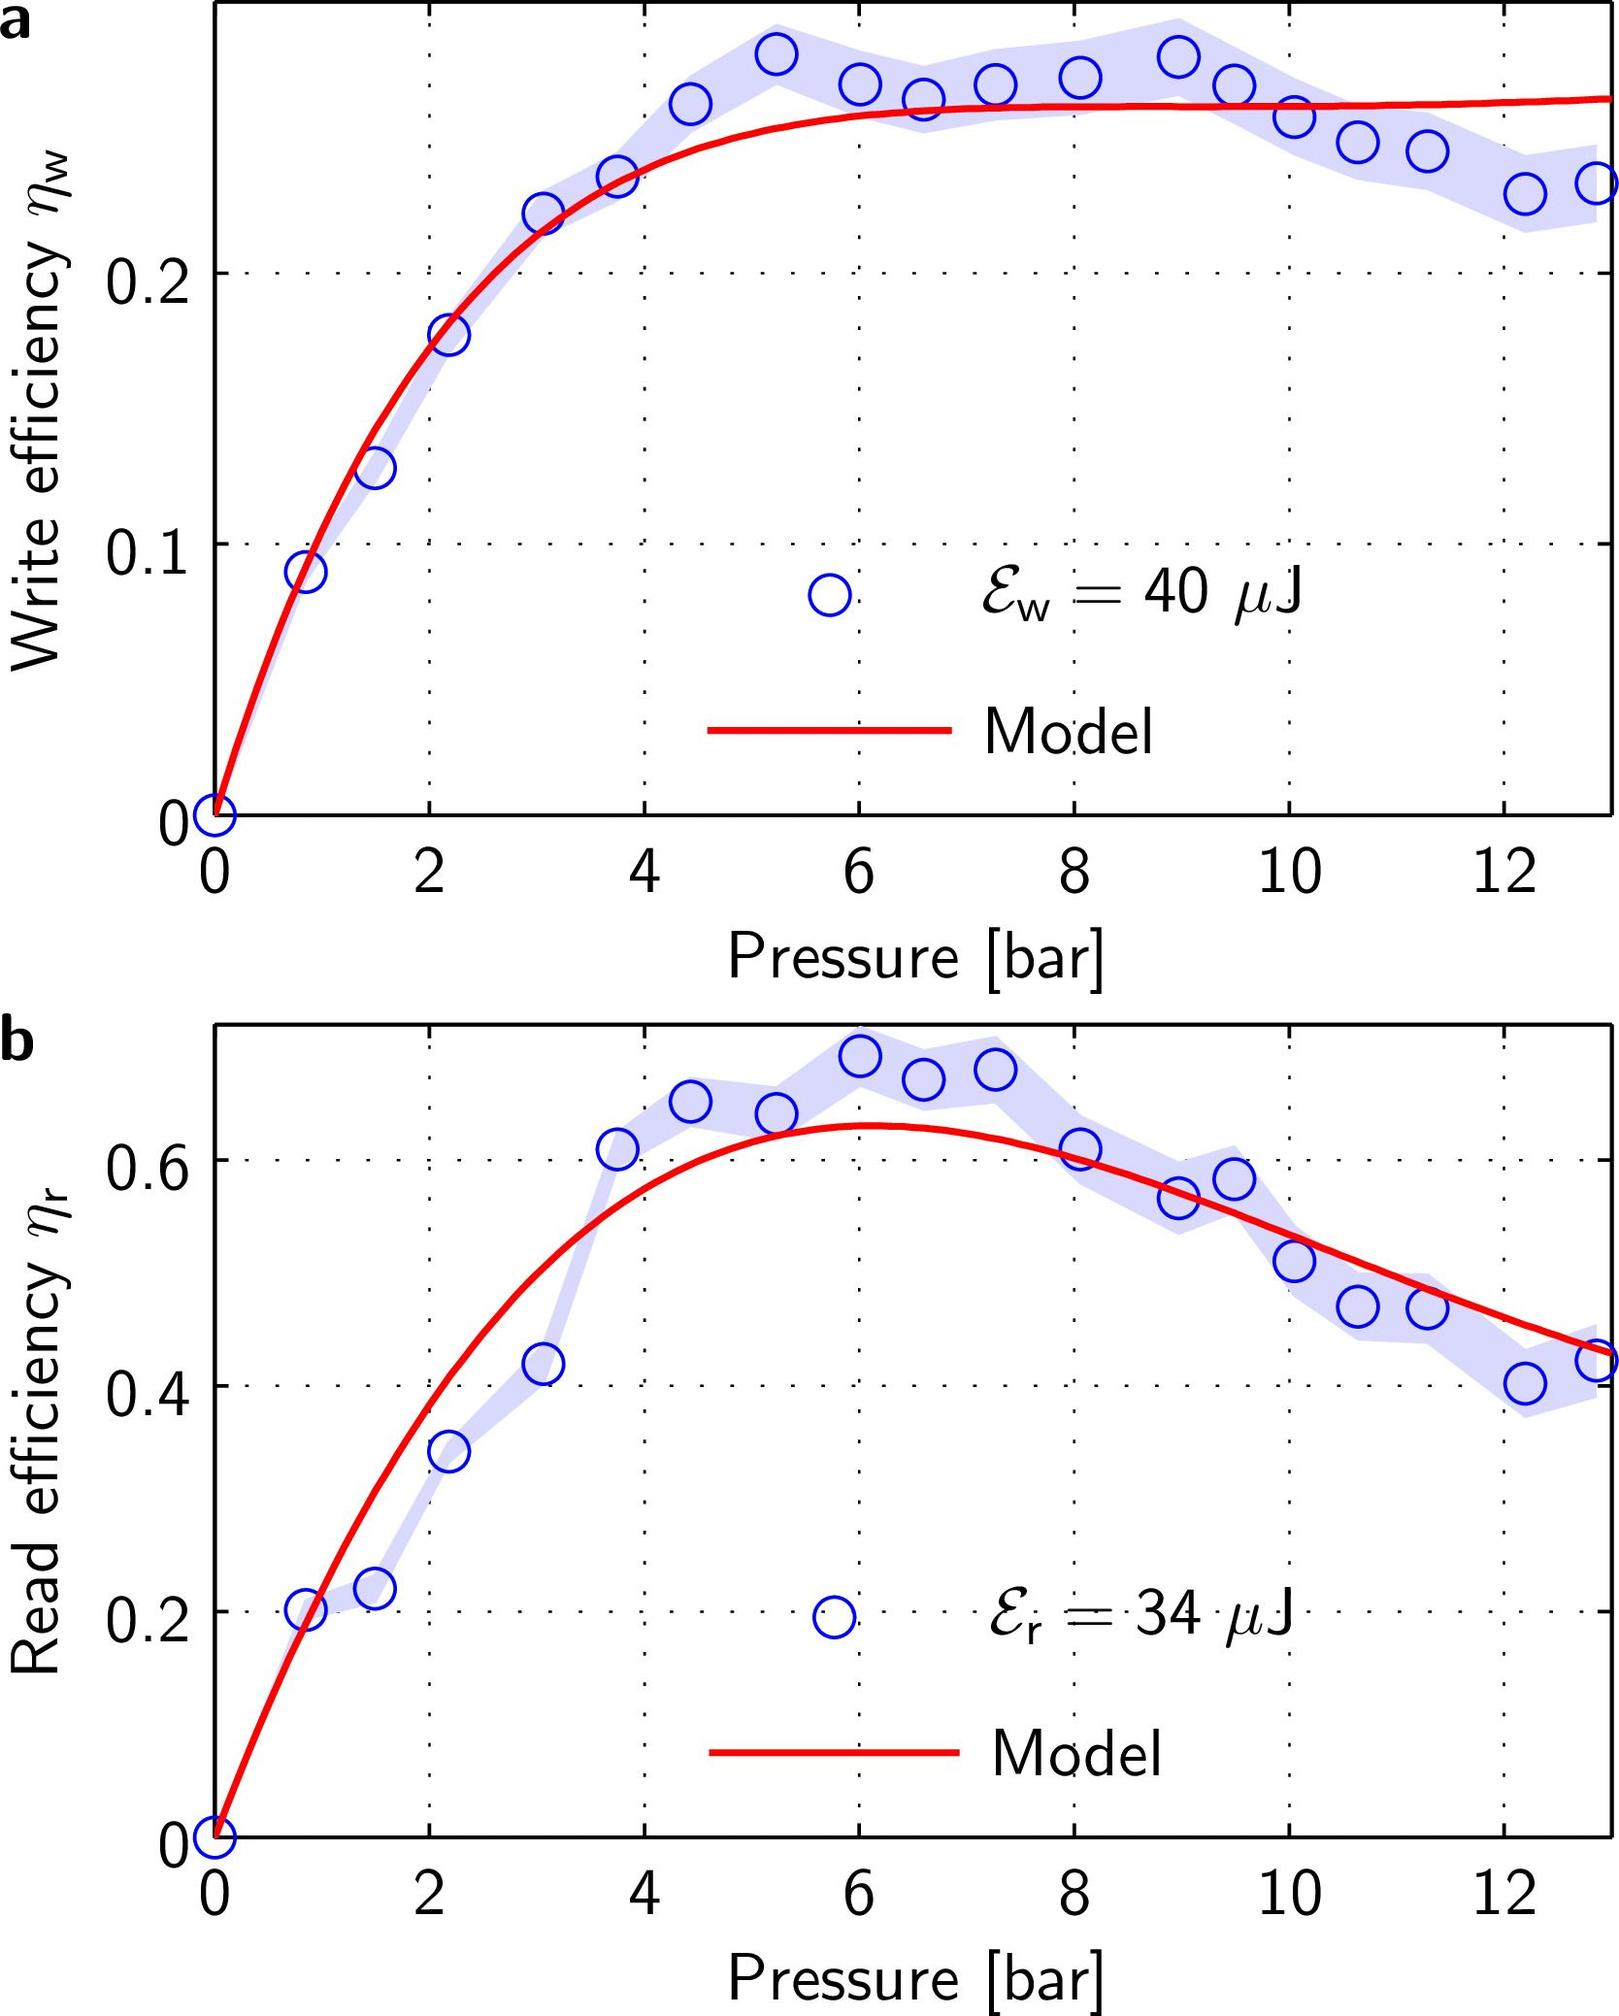Can we infer the pressure at which both reading and writing efficiencies begin to increase? From both graphs in figures a and b, it's noticeable that the initial significant increase in both write and read efficiencies begin around 2 bar pressure. This suggests that at this pressure threshold, the system starts to become significantly efficient enough to align particles during both writing and reading processes. 